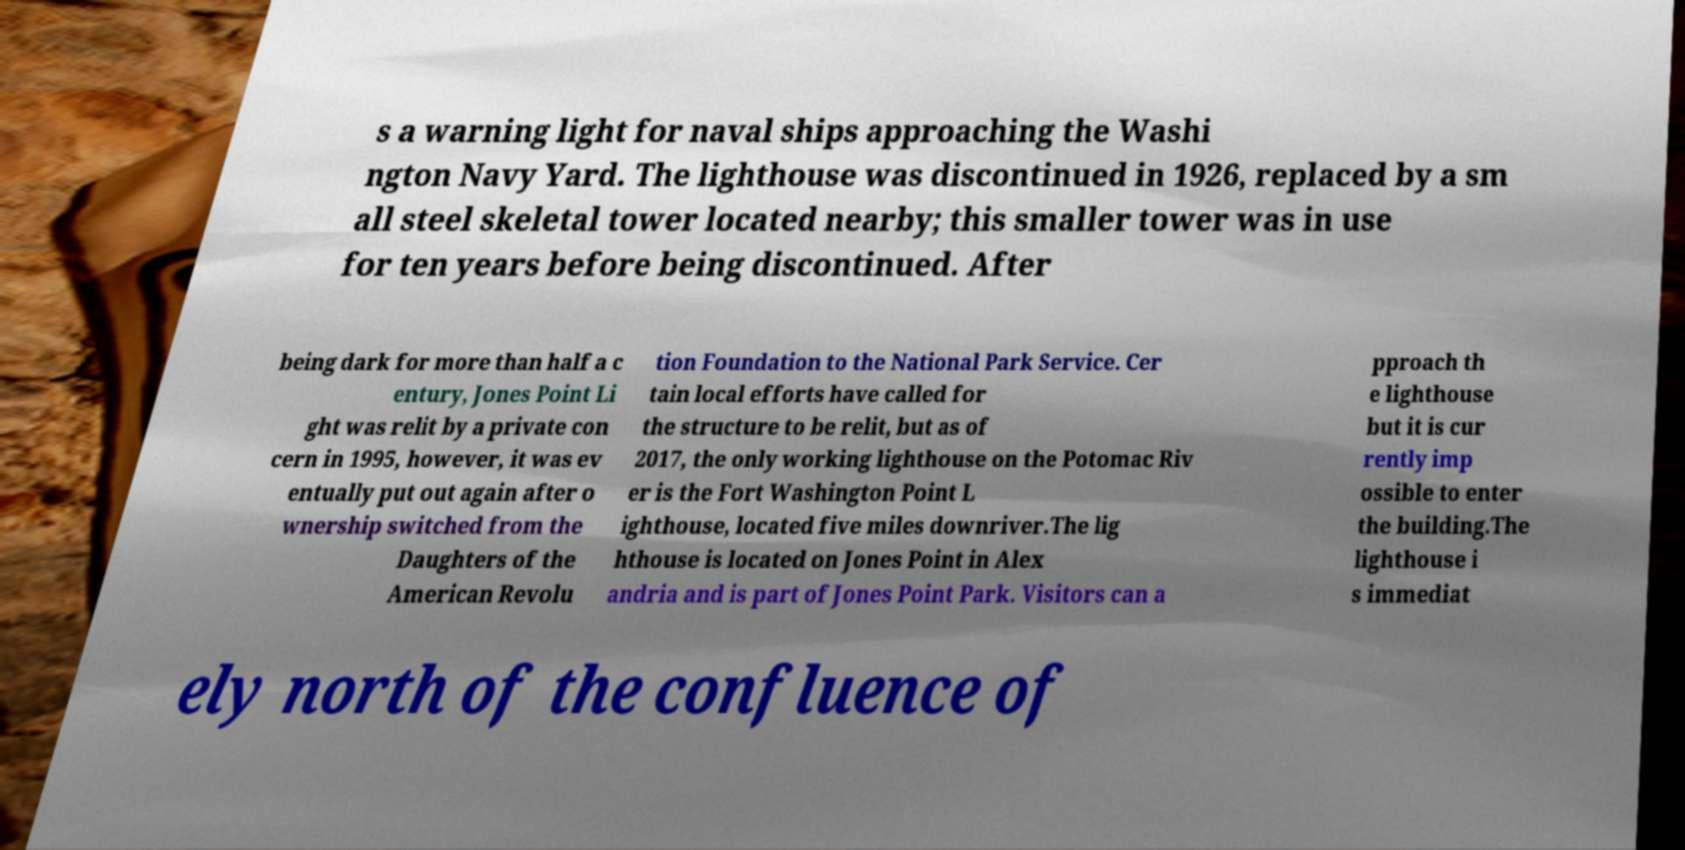Could you assist in decoding the text presented in this image and type it out clearly? s a warning light for naval ships approaching the Washi ngton Navy Yard. The lighthouse was discontinued in 1926, replaced by a sm all steel skeletal tower located nearby; this smaller tower was in use for ten years before being discontinued. After being dark for more than half a c entury, Jones Point Li ght was relit by a private con cern in 1995, however, it was ev entually put out again after o wnership switched from the Daughters of the American Revolu tion Foundation to the National Park Service. Cer tain local efforts have called for the structure to be relit, but as of 2017, the only working lighthouse on the Potomac Riv er is the Fort Washington Point L ighthouse, located five miles downriver.The lig hthouse is located on Jones Point in Alex andria and is part of Jones Point Park. Visitors can a pproach th e lighthouse but it is cur rently imp ossible to enter the building.The lighthouse i s immediat ely north of the confluence of 